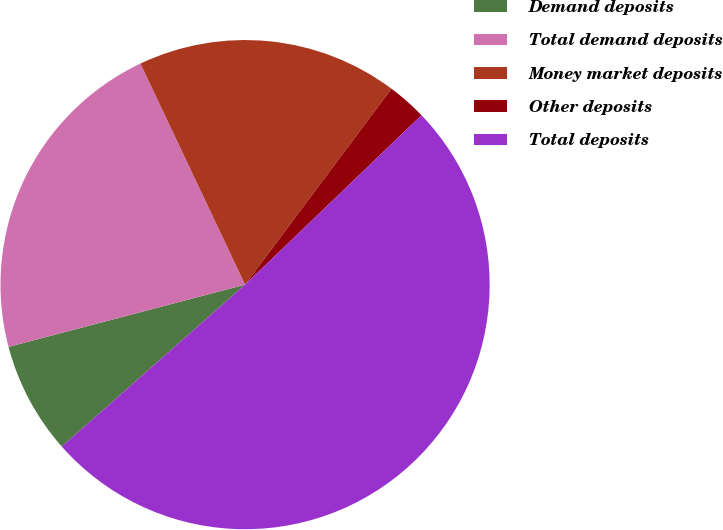<chart> <loc_0><loc_0><loc_500><loc_500><pie_chart><fcel>Demand deposits<fcel>Total demand deposits<fcel>Money market deposits<fcel>Other deposits<fcel>Total deposits<nl><fcel>7.42%<fcel>22.06%<fcel>17.25%<fcel>2.61%<fcel>50.66%<nl></chart> 